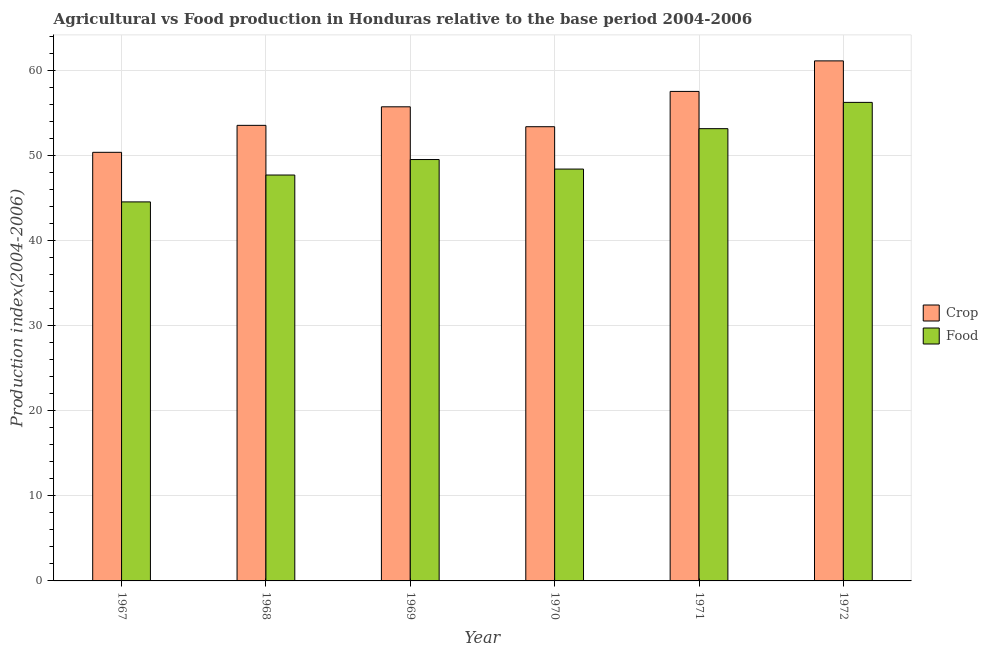How many different coloured bars are there?
Your answer should be compact. 2. Are the number of bars per tick equal to the number of legend labels?
Offer a terse response. Yes. Are the number of bars on each tick of the X-axis equal?
Offer a terse response. Yes. How many bars are there on the 1st tick from the right?
Your answer should be very brief. 2. What is the label of the 3rd group of bars from the left?
Your answer should be compact. 1969. What is the food production index in 1972?
Offer a very short reply. 56.26. Across all years, what is the maximum crop production index?
Offer a terse response. 61.14. Across all years, what is the minimum food production index?
Make the answer very short. 44.56. In which year was the crop production index maximum?
Offer a terse response. 1972. In which year was the crop production index minimum?
Your answer should be compact. 1967. What is the total crop production index in the graph?
Your response must be concise. 331.78. What is the difference between the crop production index in 1967 and that in 1969?
Your answer should be very brief. -5.35. What is the difference between the food production index in 1972 and the crop production index in 1969?
Offer a very short reply. 6.72. What is the average food production index per year?
Ensure brevity in your answer.  49.95. In the year 1970, what is the difference between the crop production index and food production index?
Offer a terse response. 0. In how many years, is the crop production index greater than 18?
Offer a very short reply. 6. What is the ratio of the crop production index in 1968 to that in 1969?
Ensure brevity in your answer.  0.96. Is the food production index in 1969 less than that in 1971?
Provide a short and direct response. Yes. What is the difference between the highest and the second highest crop production index?
Your answer should be compact. 3.59. What is the difference between the highest and the lowest food production index?
Give a very brief answer. 11.7. Is the sum of the crop production index in 1969 and 1970 greater than the maximum food production index across all years?
Ensure brevity in your answer.  Yes. What does the 1st bar from the left in 1972 represents?
Ensure brevity in your answer.  Crop. What does the 1st bar from the right in 1969 represents?
Your answer should be compact. Food. How many bars are there?
Offer a terse response. 12. Are all the bars in the graph horizontal?
Provide a short and direct response. No. Are the values on the major ticks of Y-axis written in scientific E-notation?
Provide a succinct answer. No. Does the graph contain any zero values?
Your answer should be compact. No. Where does the legend appear in the graph?
Provide a succinct answer. Center right. How many legend labels are there?
Your answer should be compact. 2. What is the title of the graph?
Ensure brevity in your answer.  Agricultural vs Food production in Honduras relative to the base period 2004-2006. What is the label or title of the X-axis?
Your answer should be compact. Year. What is the label or title of the Y-axis?
Keep it short and to the point. Production index(2004-2006). What is the Production index(2004-2006) of Crop in 1967?
Your answer should be compact. 50.39. What is the Production index(2004-2006) of Food in 1967?
Your response must be concise. 44.56. What is the Production index(2004-2006) in Crop in 1968?
Ensure brevity in your answer.  53.56. What is the Production index(2004-2006) of Food in 1968?
Provide a succinct answer. 47.72. What is the Production index(2004-2006) in Crop in 1969?
Ensure brevity in your answer.  55.74. What is the Production index(2004-2006) in Food in 1969?
Give a very brief answer. 49.54. What is the Production index(2004-2006) of Crop in 1970?
Your answer should be very brief. 53.4. What is the Production index(2004-2006) of Food in 1970?
Make the answer very short. 48.42. What is the Production index(2004-2006) in Crop in 1971?
Offer a very short reply. 57.55. What is the Production index(2004-2006) of Food in 1971?
Keep it short and to the point. 53.17. What is the Production index(2004-2006) in Crop in 1972?
Keep it short and to the point. 61.14. What is the Production index(2004-2006) in Food in 1972?
Offer a very short reply. 56.26. Across all years, what is the maximum Production index(2004-2006) in Crop?
Offer a terse response. 61.14. Across all years, what is the maximum Production index(2004-2006) in Food?
Your answer should be compact. 56.26. Across all years, what is the minimum Production index(2004-2006) of Crop?
Provide a succinct answer. 50.39. Across all years, what is the minimum Production index(2004-2006) of Food?
Offer a terse response. 44.56. What is the total Production index(2004-2006) in Crop in the graph?
Your answer should be compact. 331.78. What is the total Production index(2004-2006) of Food in the graph?
Your answer should be compact. 299.67. What is the difference between the Production index(2004-2006) of Crop in 1967 and that in 1968?
Keep it short and to the point. -3.17. What is the difference between the Production index(2004-2006) of Food in 1967 and that in 1968?
Give a very brief answer. -3.16. What is the difference between the Production index(2004-2006) of Crop in 1967 and that in 1969?
Make the answer very short. -5.35. What is the difference between the Production index(2004-2006) in Food in 1967 and that in 1969?
Offer a terse response. -4.98. What is the difference between the Production index(2004-2006) in Crop in 1967 and that in 1970?
Offer a very short reply. -3.01. What is the difference between the Production index(2004-2006) in Food in 1967 and that in 1970?
Your answer should be very brief. -3.86. What is the difference between the Production index(2004-2006) of Crop in 1967 and that in 1971?
Make the answer very short. -7.16. What is the difference between the Production index(2004-2006) in Food in 1967 and that in 1971?
Offer a terse response. -8.61. What is the difference between the Production index(2004-2006) of Crop in 1967 and that in 1972?
Give a very brief answer. -10.75. What is the difference between the Production index(2004-2006) of Food in 1967 and that in 1972?
Your answer should be compact. -11.7. What is the difference between the Production index(2004-2006) of Crop in 1968 and that in 1969?
Offer a terse response. -2.18. What is the difference between the Production index(2004-2006) in Food in 1968 and that in 1969?
Provide a succinct answer. -1.82. What is the difference between the Production index(2004-2006) in Crop in 1968 and that in 1970?
Keep it short and to the point. 0.16. What is the difference between the Production index(2004-2006) of Food in 1968 and that in 1970?
Make the answer very short. -0.7. What is the difference between the Production index(2004-2006) in Crop in 1968 and that in 1971?
Give a very brief answer. -3.99. What is the difference between the Production index(2004-2006) in Food in 1968 and that in 1971?
Ensure brevity in your answer.  -5.45. What is the difference between the Production index(2004-2006) of Crop in 1968 and that in 1972?
Provide a short and direct response. -7.58. What is the difference between the Production index(2004-2006) of Food in 1968 and that in 1972?
Provide a short and direct response. -8.54. What is the difference between the Production index(2004-2006) in Crop in 1969 and that in 1970?
Offer a terse response. 2.34. What is the difference between the Production index(2004-2006) in Food in 1969 and that in 1970?
Give a very brief answer. 1.12. What is the difference between the Production index(2004-2006) of Crop in 1969 and that in 1971?
Your answer should be very brief. -1.81. What is the difference between the Production index(2004-2006) in Food in 1969 and that in 1971?
Ensure brevity in your answer.  -3.63. What is the difference between the Production index(2004-2006) in Food in 1969 and that in 1972?
Keep it short and to the point. -6.72. What is the difference between the Production index(2004-2006) of Crop in 1970 and that in 1971?
Your answer should be very brief. -4.15. What is the difference between the Production index(2004-2006) in Food in 1970 and that in 1971?
Your answer should be very brief. -4.75. What is the difference between the Production index(2004-2006) of Crop in 1970 and that in 1972?
Give a very brief answer. -7.74. What is the difference between the Production index(2004-2006) of Food in 1970 and that in 1972?
Provide a short and direct response. -7.84. What is the difference between the Production index(2004-2006) in Crop in 1971 and that in 1972?
Offer a terse response. -3.59. What is the difference between the Production index(2004-2006) in Food in 1971 and that in 1972?
Ensure brevity in your answer.  -3.09. What is the difference between the Production index(2004-2006) in Crop in 1967 and the Production index(2004-2006) in Food in 1968?
Your answer should be very brief. 2.67. What is the difference between the Production index(2004-2006) of Crop in 1967 and the Production index(2004-2006) of Food in 1970?
Provide a succinct answer. 1.97. What is the difference between the Production index(2004-2006) of Crop in 1967 and the Production index(2004-2006) of Food in 1971?
Provide a succinct answer. -2.78. What is the difference between the Production index(2004-2006) in Crop in 1967 and the Production index(2004-2006) in Food in 1972?
Offer a terse response. -5.87. What is the difference between the Production index(2004-2006) of Crop in 1968 and the Production index(2004-2006) of Food in 1969?
Your answer should be very brief. 4.02. What is the difference between the Production index(2004-2006) in Crop in 1968 and the Production index(2004-2006) in Food in 1970?
Provide a succinct answer. 5.14. What is the difference between the Production index(2004-2006) in Crop in 1968 and the Production index(2004-2006) in Food in 1971?
Make the answer very short. 0.39. What is the difference between the Production index(2004-2006) of Crop in 1969 and the Production index(2004-2006) of Food in 1970?
Provide a succinct answer. 7.32. What is the difference between the Production index(2004-2006) in Crop in 1969 and the Production index(2004-2006) in Food in 1971?
Offer a terse response. 2.57. What is the difference between the Production index(2004-2006) of Crop in 1969 and the Production index(2004-2006) of Food in 1972?
Keep it short and to the point. -0.52. What is the difference between the Production index(2004-2006) in Crop in 1970 and the Production index(2004-2006) in Food in 1971?
Your answer should be compact. 0.23. What is the difference between the Production index(2004-2006) of Crop in 1970 and the Production index(2004-2006) of Food in 1972?
Make the answer very short. -2.86. What is the difference between the Production index(2004-2006) in Crop in 1971 and the Production index(2004-2006) in Food in 1972?
Provide a short and direct response. 1.29. What is the average Production index(2004-2006) of Crop per year?
Your answer should be very brief. 55.3. What is the average Production index(2004-2006) in Food per year?
Keep it short and to the point. 49.95. In the year 1967, what is the difference between the Production index(2004-2006) of Crop and Production index(2004-2006) of Food?
Your response must be concise. 5.83. In the year 1968, what is the difference between the Production index(2004-2006) in Crop and Production index(2004-2006) in Food?
Give a very brief answer. 5.84. In the year 1969, what is the difference between the Production index(2004-2006) of Crop and Production index(2004-2006) of Food?
Offer a very short reply. 6.2. In the year 1970, what is the difference between the Production index(2004-2006) of Crop and Production index(2004-2006) of Food?
Make the answer very short. 4.98. In the year 1971, what is the difference between the Production index(2004-2006) of Crop and Production index(2004-2006) of Food?
Give a very brief answer. 4.38. In the year 1972, what is the difference between the Production index(2004-2006) of Crop and Production index(2004-2006) of Food?
Offer a very short reply. 4.88. What is the ratio of the Production index(2004-2006) of Crop in 1967 to that in 1968?
Provide a succinct answer. 0.94. What is the ratio of the Production index(2004-2006) of Food in 1967 to that in 1968?
Your answer should be very brief. 0.93. What is the ratio of the Production index(2004-2006) of Crop in 1967 to that in 1969?
Make the answer very short. 0.9. What is the ratio of the Production index(2004-2006) of Food in 1967 to that in 1969?
Your response must be concise. 0.9. What is the ratio of the Production index(2004-2006) in Crop in 1967 to that in 1970?
Provide a succinct answer. 0.94. What is the ratio of the Production index(2004-2006) in Food in 1967 to that in 1970?
Your response must be concise. 0.92. What is the ratio of the Production index(2004-2006) in Crop in 1967 to that in 1971?
Your answer should be very brief. 0.88. What is the ratio of the Production index(2004-2006) of Food in 1967 to that in 1971?
Keep it short and to the point. 0.84. What is the ratio of the Production index(2004-2006) of Crop in 1967 to that in 1972?
Your answer should be compact. 0.82. What is the ratio of the Production index(2004-2006) in Food in 1967 to that in 1972?
Ensure brevity in your answer.  0.79. What is the ratio of the Production index(2004-2006) of Crop in 1968 to that in 1969?
Your answer should be very brief. 0.96. What is the ratio of the Production index(2004-2006) of Food in 1968 to that in 1969?
Offer a very short reply. 0.96. What is the ratio of the Production index(2004-2006) in Crop in 1968 to that in 1970?
Offer a terse response. 1. What is the ratio of the Production index(2004-2006) in Food in 1968 to that in 1970?
Your answer should be compact. 0.99. What is the ratio of the Production index(2004-2006) in Crop in 1968 to that in 1971?
Provide a succinct answer. 0.93. What is the ratio of the Production index(2004-2006) in Food in 1968 to that in 1971?
Your answer should be compact. 0.9. What is the ratio of the Production index(2004-2006) of Crop in 1968 to that in 1972?
Your answer should be very brief. 0.88. What is the ratio of the Production index(2004-2006) in Food in 1968 to that in 1972?
Your answer should be compact. 0.85. What is the ratio of the Production index(2004-2006) of Crop in 1969 to that in 1970?
Offer a very short reply. 1.04. What is the ratio of the Production index(2004-2006) of Food in 1969 to that in 1970?
Your answer should be very brief. 1.02. What is the ratio of the Production index(2004-2006) of Crop in 1969 to that in 1971?
Provide a succinct answer. 0.97. What is the ratio of the Production index(2004-2006) in Food in 1969 to that in 1971?
Make the answer very short. 0.93. What is the ratio of the Production index(2004-2006) of Crop in 1969 to that in 1972?
Make the answer very short. 0.91. What is the ratio of the Production index(2004-2006) in Food in 1969 to that in 1972?
Provide a short and direct response. 0.88. What is the ratio of the Production index(2004-2006) in Crop in 1970 to that in 1971?
Your answer should be compact. 0.93. What is the ratio of the Production index(2004-2006) of Food in 1970 to that in 1971?
Make the answer very short. 0.91. What is the ratio of the Production index(2004-2006) in Crop in 1970 to that in 1972?
Provide a succinct answer. 0.87. What is the ratio of the Production index(2004-2006) in Food in 1970 to that in 1972?
Provide a succinct answer. 0.86. What is the ratio of the Production index(2004-2006) of Crop in 1971 to that in 1972?
Keep it short and to the point. 0.94. What is the ratio of the Production index(2004-2006) in Food in 1971 to that in 1972?
Make the answer very short. 0.95. What is the difference between the highest and the second highest Production index(2004-2006) in Crop?
Your answer should be very brief. 3.59. What is the difference between the highest and the second highest Production index(2004-2006) in Food?
Provide a short and direct response. 3.09. What is the difference between the highest and the lowest Production index(2004-2006) of Crop?
Offer a terse response. 10.75. 